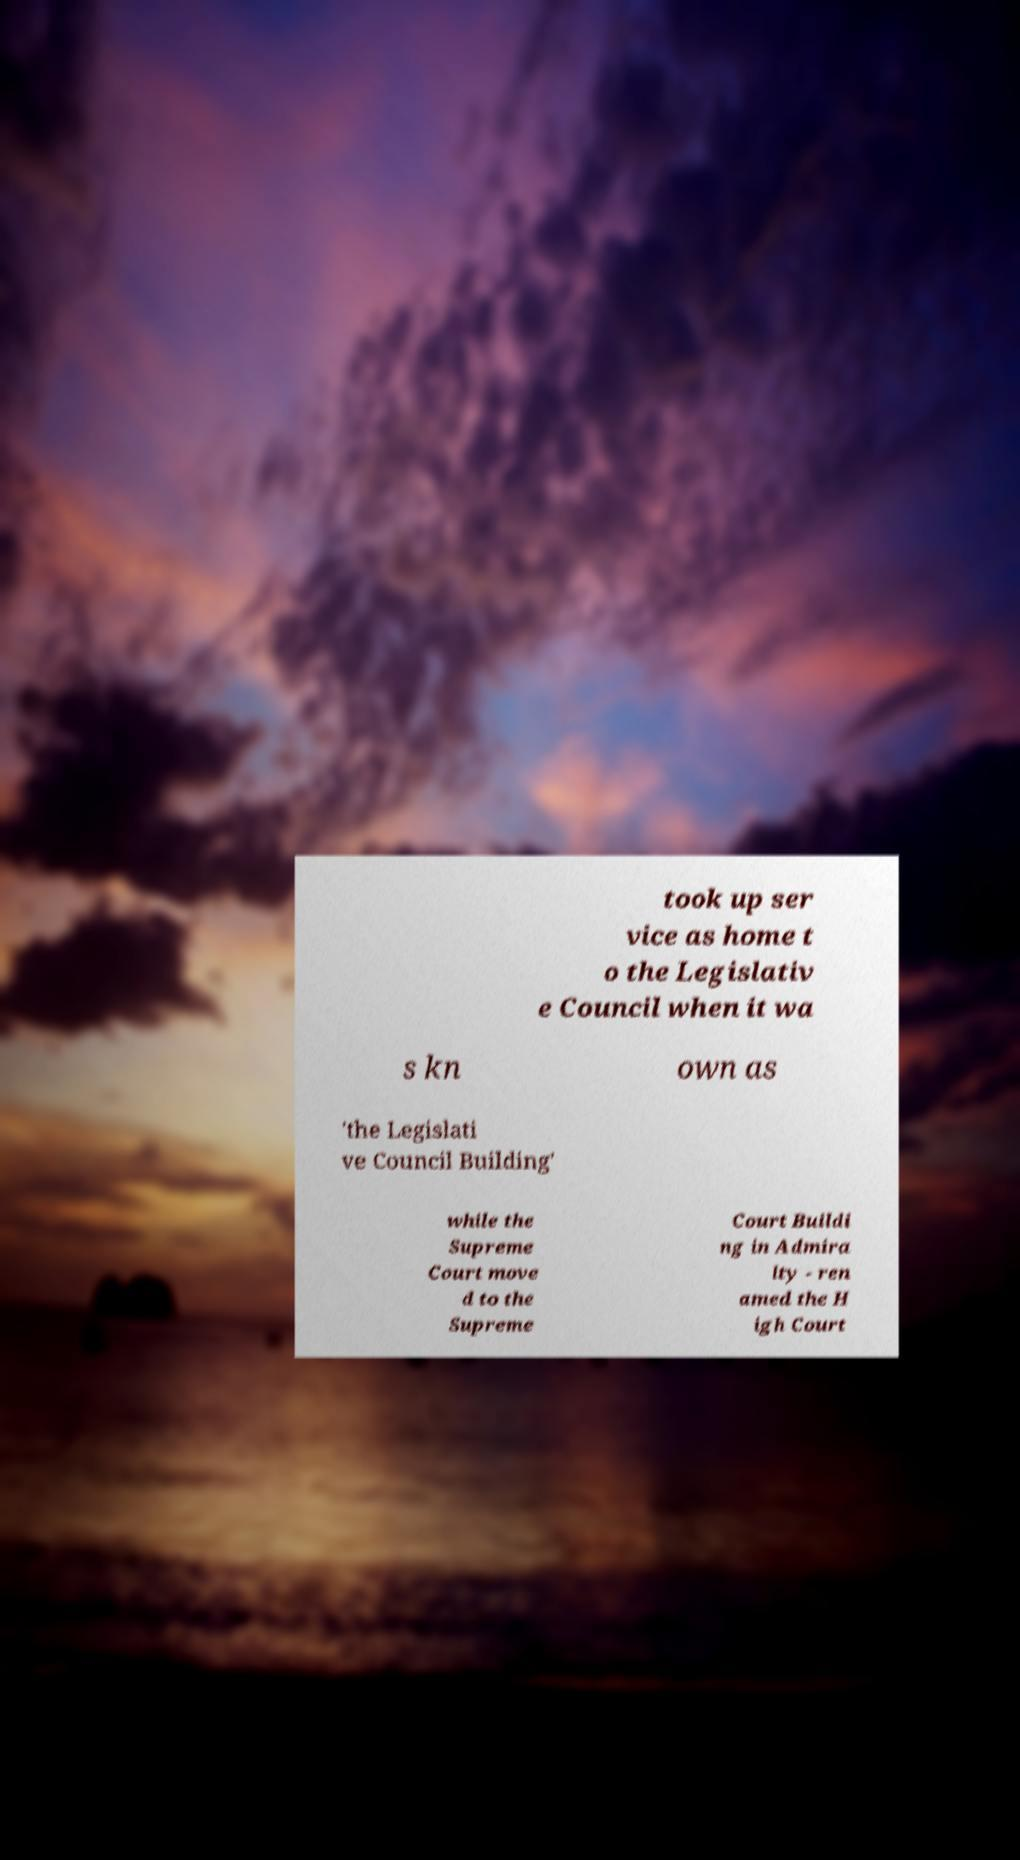For documentation purposes, I need the text within this image transcribed. Could you provide that? took up ser vice as home t o the Legislativ e Council when it wa s kn own as 'the Legislati ve Council Building' while the Supreme Court move d to the Supreme Court Buildi ng in Admira lty - ren amed the H igh Court 